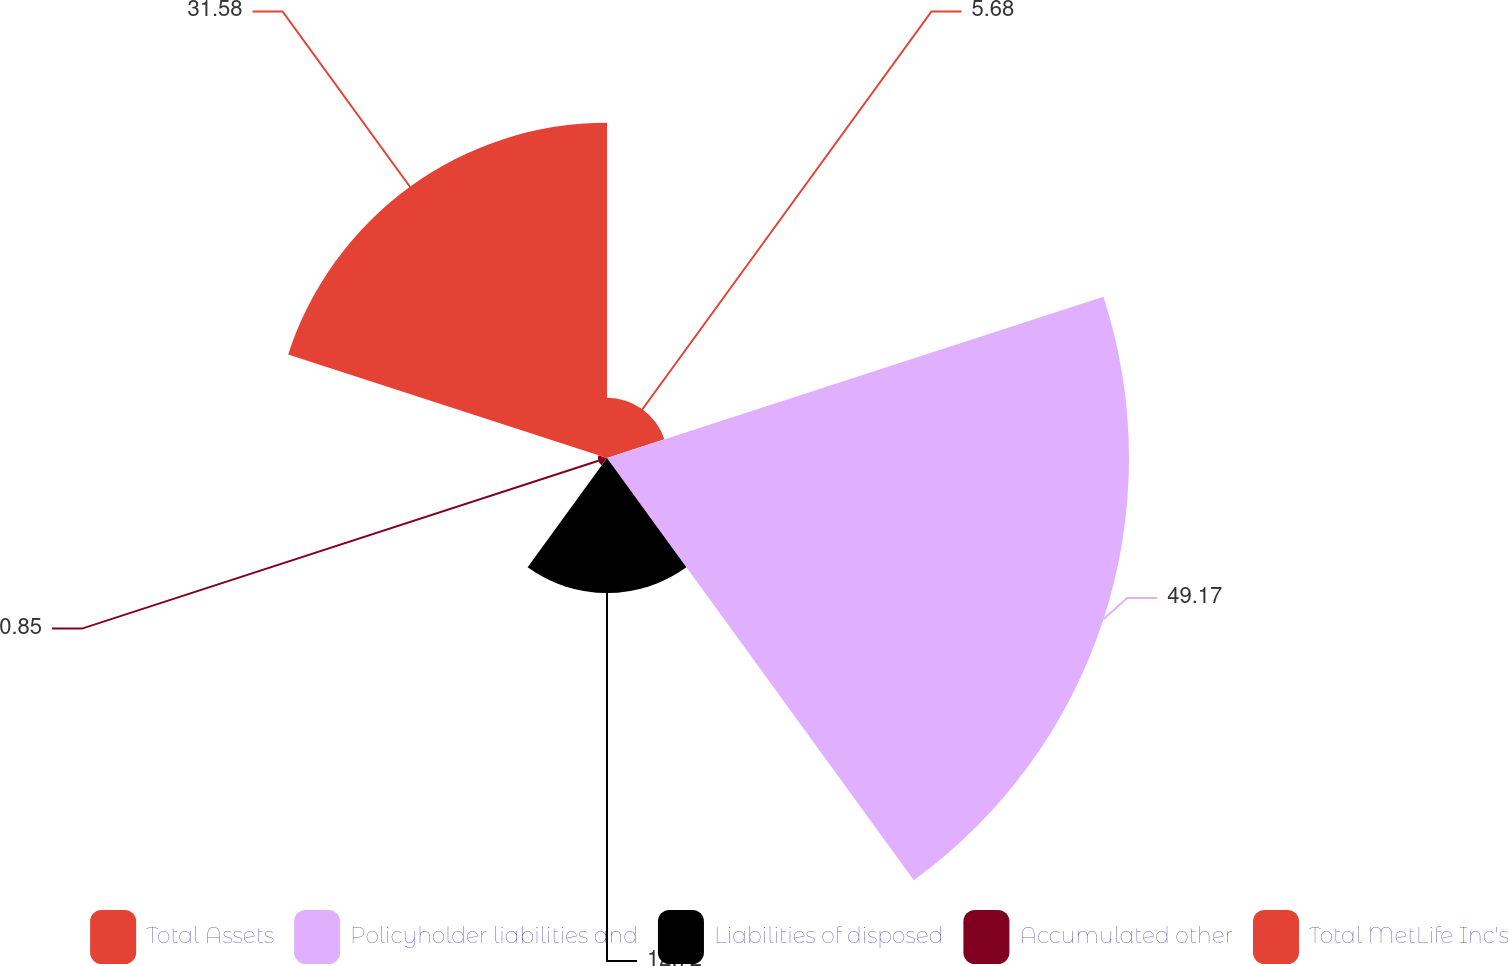<chart> <loc_0><loc_0><loc_500><loc_500><pie_chart><fcel>Total Assets<fcel>Policyholder liabilities and<fcel>Liabilities of disposed<fcel>Accumulated other<fcel>Total MetLife Inc's<nl><fcel>5.68%<fcel>49.17%<fcel>12.72%<fcel>0.85%<fcel>31.58%<nl></chart> 